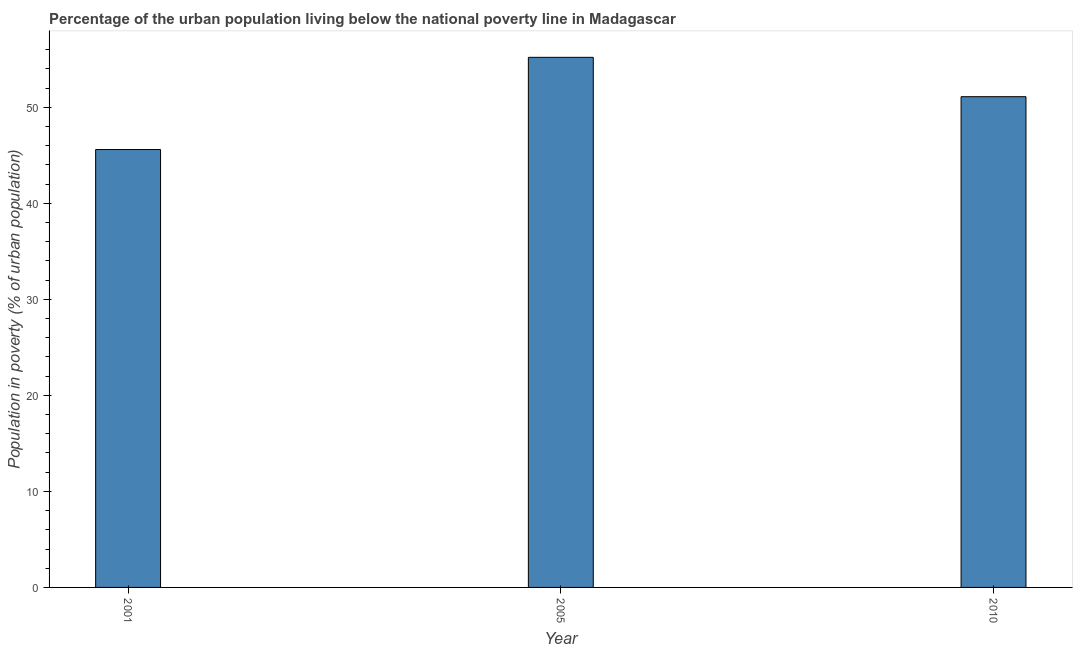Does the graph contain any zero values?
Offer a very short reply. No. What is the title of the graph?
Give a very brief answer. Percentage of the urban population living below the national poverty line in Madagascar. What is the label or title of the X-axis?
Make the answer very short. Year. What is the label or title of the Y-axis?
Keep it short and to the point. Population in poverty (% of urban population). What is the percentage of urban population living below poverty line in 2001?
Provide a short and direct response. 45.6. Across all years, what is the maximum percentage of urban population living below poverty line?
Keep it short and to the point. 55.2. Across all years, what is the minimum percentage of urban population living below poverty line?
Your answer should be compact. 45.6. In which year was the percentage of urban population living below poverty line maximum?
Make the answer very short. 2005. What is the sum of the percentage of urban population living below poverty line?
Offer a terse response. 151.9. What is the difference between the percentage of urban population living below poverty line in 2001 and 2005?
Offer a terse response. -9.6. What is the average percentage of urban population living below poverty line per year?
Provide a short and direct response. 50.63. What is the median percentage of urban population living below poverty line?
Make the answer very short. 51.1. Do a majority of the years between 2010 and 2005 (inclusive) have percentage of urban population living below poverty line greater than 8 %?
Your answer should be compact. No. What is the ratio of the percentage of urban population living below poverty line in 2005 to that in 2010?
Keep it short and to the point. 1.08. Is the percentage of urban population living below poverty line in 2001 less than that in 2005?
Keep it short and to the point. Yes. Is the sum of the percentage of urban population living below poverty line in 2001 and 2005 greater than the maximum percentage of urban population living below poverty line across all years?
Your answer should be compact. Yes. How many years are there in the graph?
Make the answer very short. 3. What is the Population in poverty (% of urban population) of 2001?
Give a very brief answer. 45.6. What is the Population in poverty (% of urban population) in 2005?
Offer a very short reply. 55.2. What is the Population in poverty (% of urban population) in 2010?
Your response must be concise. 51.1. What is the difference between the Population in poverty (% of urban population) in 2005 and 2010?
Keep it short and to the point. 4.1. What is the ratio of the Population in poverty (% of urban population) in 2001 to that in 2005?
Give a very brief answer. 0.83. What is the ratio of the Population in poverty (% of urban population) in 2001 to that in 2010?
Your response must be concise. 0.89. 